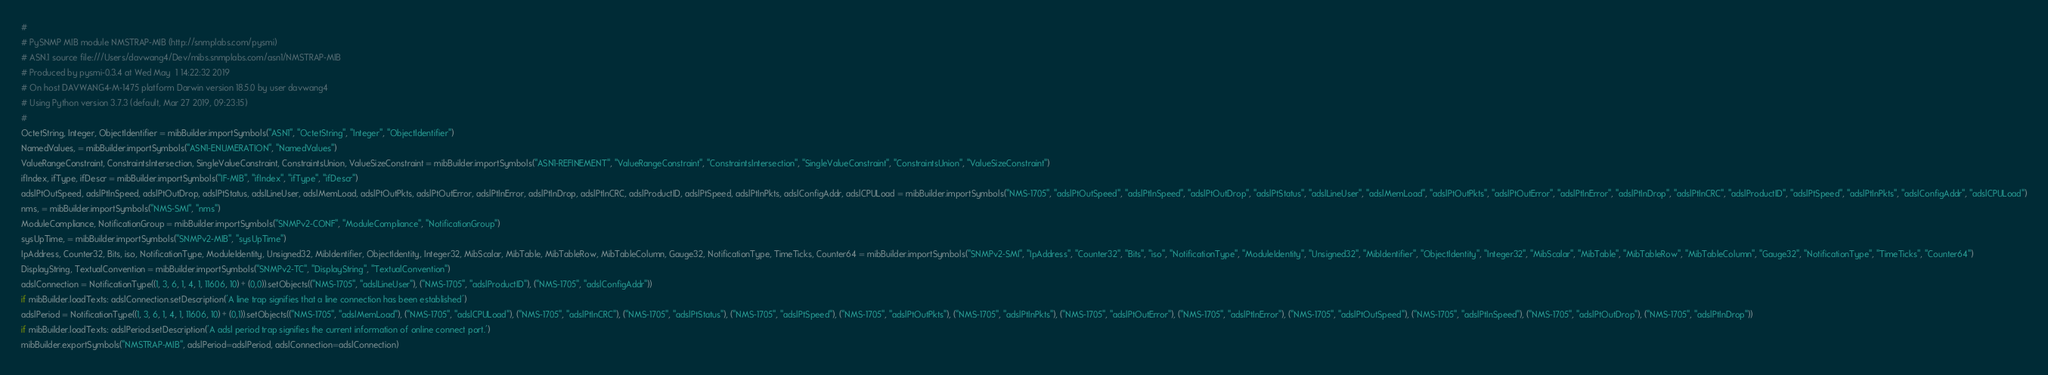<code> <loc_0><loc_0><loc_500><loc_500><_Python_>#
# PySNMP MIB module NMSTRAP-MIB (http://snmplabs.com/pysmi)
# ASN.1 source file:///Users/davwang4/Dev/mibs.snmplabs.com/asn1/NMSTRAP-MIB
# Produced by pysmi-0.3.4 at Wed May  1 14:22:32 2019
# On host DAVWANG4-M-1475 platform Darwin version 18.5.0 by user davwang4
# Using Python version 3.7.3 (default, Mar 27 2019, 09:23:15) 
#
OctetString, Integer, ObjectIdentifier = mibBuilder.importSymbols("ASN1", "OctetString", "Integer", "ObjectIdentifier")
NamedValues, = mibBuilder.importSymbols("ASN1-ENUMERATION", "NamedValues")
ValueRangeConstraint, ConstraintsIntersection, SingleValueConstraint, ConstraintsUnion, ValueSizeConstraint = mibBuilder.importSymbols("ASN1-REFINEMENT", "ValueRangeConstraint", "ConstraintsIntersection", "SingleValueConstraint", "ConstraintsUnion", "ValueSizeConstraint")
ifIndex, ifType, ifDescr = mibBuilder.importSymbols("IF-MIB", "ifIndex", "ifType", "ifDescr")
adslPtOutSpeed, adslPtInSpeed, adslPtOutDrop, adslPtStatus, adslLineUser, adslMemLoad, adslPtOutPkts, adslPtOutError, adslPtInError, adslPtInDrop, adslPtInCRC, adslProductID, adslPtSpeed, adslPtInPkts, adslConfigAddr, adslCPULoad = mibBuilder.importSymbols("NMS-1705", "adslPtOutSpeed", "adslPtInSpeed", "adslPtOutDrop", "adslPtStatus", "adslLineUser", "adslMemLoad", "adslPtOutPkts", "adslPtOutError", "adslPtInError", "adslPtInDrop", "adslPtInCRC", "adslProductID", "adslPtSpeed", "adslPtInPkts", "adslConfigAddr", "adslCPULoad")
nms, = mibBuilder.importSymbols("NMS-SMI", "nms")
ModuleCompliance, NotificationGroup = mibBuilder.importSymbols("SNMPv2-CONF", "ModuleCompliance", "NotificationGroup")
sysUpTime, = mibBuilder.importSymbols("SNMPv2-MIB", "sysUpTime")
IpAddress, Counter32, Bits, iso, NotificationType, ModuleIdentity, Unsigned32, MibIdentifier, ObjectIdentity, Integer32, MibScalar, MibTable, MibTableRow, MibTableColumn, Gauge32, NotificationType, TimeTicks, Counter64 = mibBuilder.importSymbols("SNMPv2-SMI", "IpAddress", "Counter32", "Bits", "iso", "NotificationType", "ModuleIdentity", "Unsigned32", "MibIdentifier", "ObjectIdentity", "Integer32", "MibScalar", "MibTable", "MibTableRow", "MibTableColumn", "Gauge32", "NotificationType", "TimeTicks", "Counter64")
DisplayString, TextualConvention = mibBuilder.importSymbols("SNMPv2-TC", "DisplayString", "TextualConvention")
adslConnection = NotificationType((1, 3, 6, 1, 4, 1, 11606, 10) + (0,0)).setObjects(("NMS-1705", "adslLineUser"), ("NMS-1705", "adslProductID"), ("NMS-1705", "adslConfigAddr"))
if mibBuilder.loadTexts: adslConnection.setDescription('A line trap signifies that a line connection has been established')
adslPeriod = NotificationType((1, 3, 6, 1, 4, 1, 11606, 10) + (0,1)).setObjects(("NMS-1705", "adslMemLoad"), ("NMS-1705", "adslCPULoad"), ("NMS-1705", "adslPtInCRC"), ("NMS-1705", "adslPtStatus"), ("NMS-1705", "adslPtSpeed"), ("NMS-1705", "adslPtOutPkts"), ("NMS-1705", "adslPtInPkts"), ("NMS-1705", "adslPtOutError"), ("NMS-1705", "adslPtInError"), ("NMS-1705", "adslPtOutSpeed"), ("NMS-1705", "adslPtInSpeed"), ("NMS-1705", "adslPtOutDrop"), ("NMS-1705", "adslPtInDrop"))
if mibBuilder.loadTexts: adslPeriod.setDescription('A adsl period trap signifies the current information of online connect port.')
mibBuilder.exportSymbols("NMSTRAP-MIB", adslPeriod=adslPeriod, adslConnection=adslConnection)
</code> 